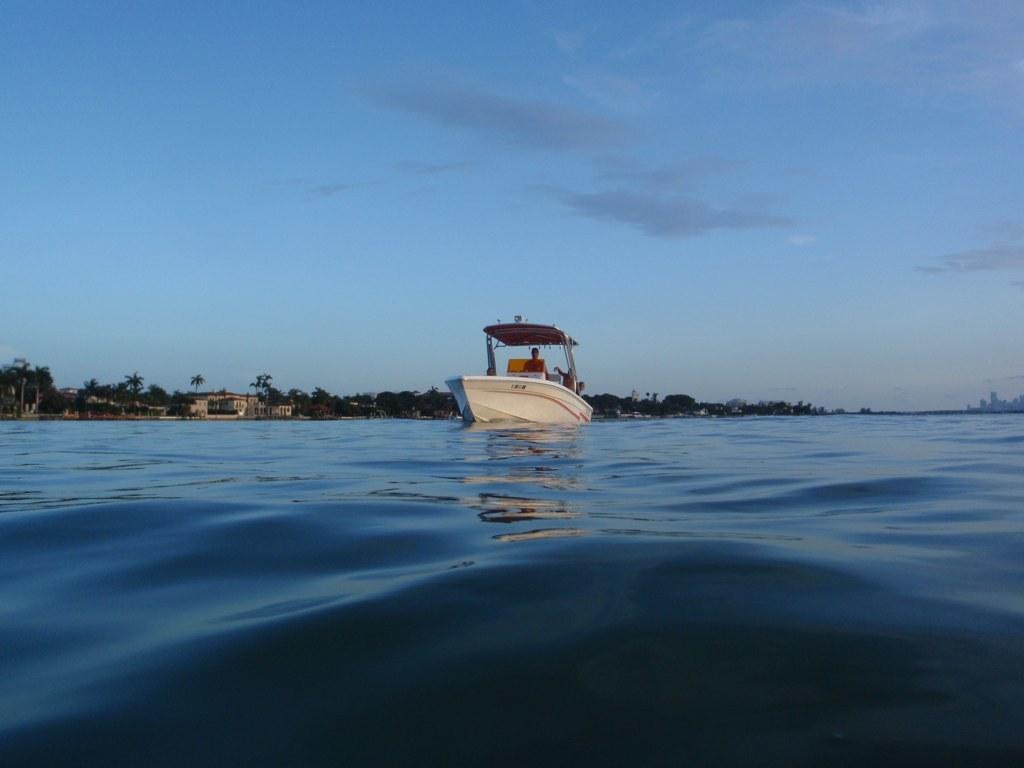In one or two sentences, can you explain what this image depicts? In this image, we can see a person on the boat and in the background, there are trees and buildings. At the bottom, there is water and at the top, there is sky. 